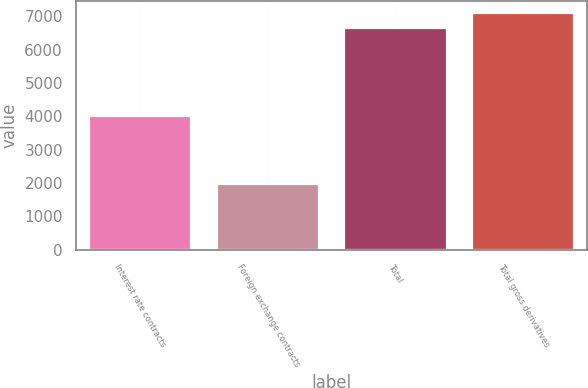Convert chart. <chart><loc_0><loc_0><loc_500><loc_500><bar_chart><fcel>Interest rate contracts<fcel>Foreign exchange contracts<fcel>Total<fcel>Total gross derivatives<nl><fcel>3999<fcel>1960<fcel>6636<fcel>7106<nl></chart> 